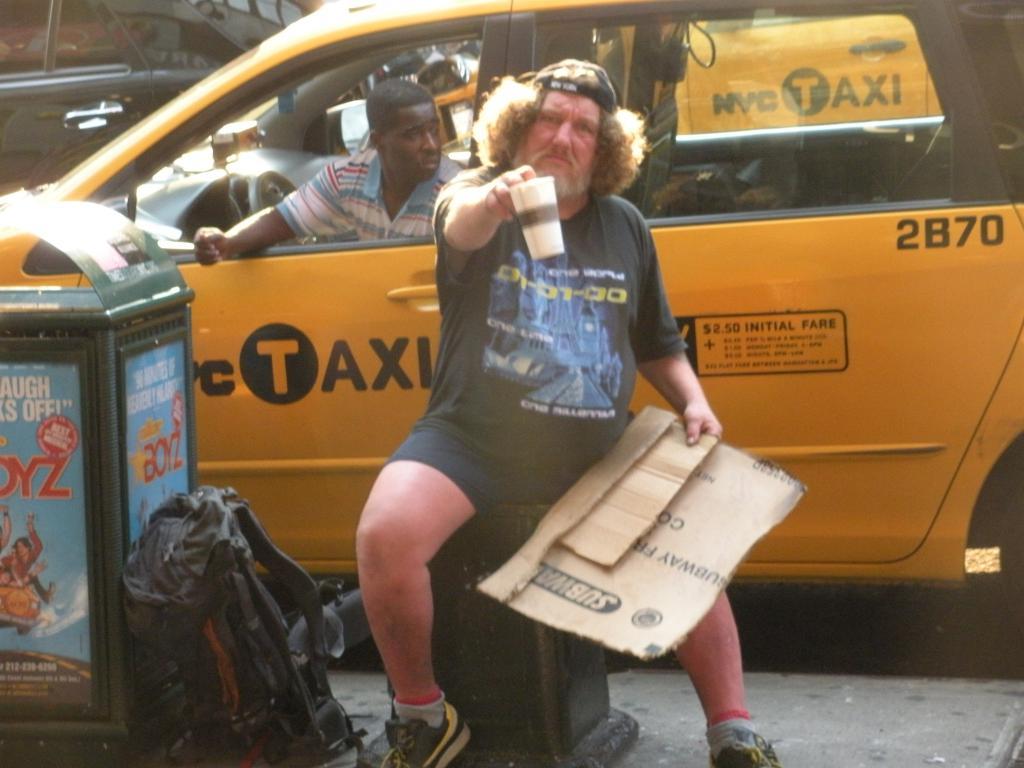What number is the cab?
Give a very brief answer. 2b70. 